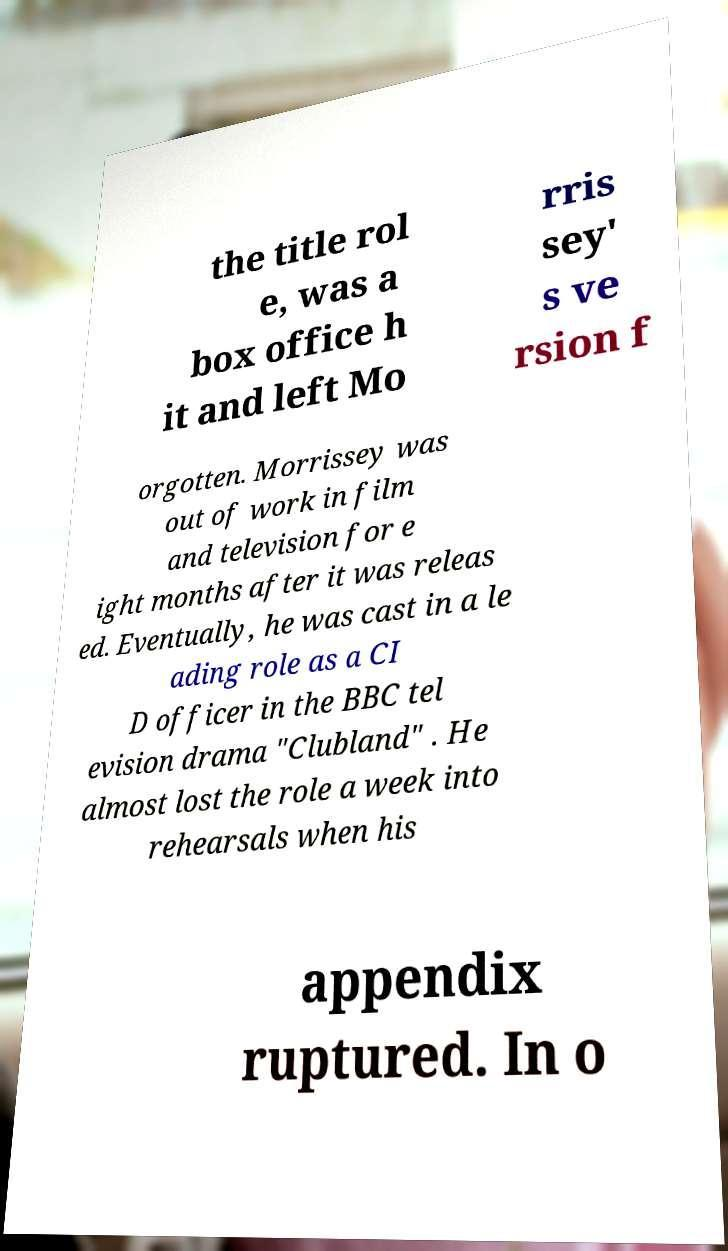Could you extract and type out the text from this image? the title rol e, was a box office h it and left Mo rris sey' s ve rsion f orgotten. Morrissey was out of work in film and television for e ight months after it was releas ed. Eventually, he was cast in a le ading role as a CI D officer in the BBC tel evision drama "Clubland" . He almost lost the role a week into rehearsals when his appendix ruptured. In o 